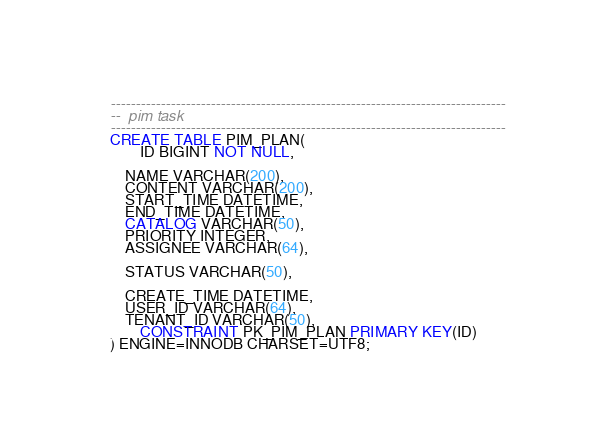<code> <loc_0><loc_0><loc_500><loc_500><_SQL_>

-------------------------------------------------------------------------------
--  pim task
-------------------------------------------------------------------------------
CREATE TABLE PIM_PLAN(
        ID BIGINT NOT NULL,
        
	NAME VARCHAR(200),
	CONTENT VARCHAR(200),
	START_TIME DATETIME,
	END_TIME DATETIME,
	CATALOG VARCHAR(50),
	PRIORITY INTEGER,
	ASSIGNEE VARCHAR(64),

	STATUS VARCHAR(50),

	CREATE_TIME DATETIME,
	USER_ID VARCHAR(64),
	TENANT_ID VARCHAR(50),
        CONSTRAINT PK_PIM_PLAN PRIMARY KEY(ID)
) ENGINE=INNODB CHARSET=UTF8;


</code> 